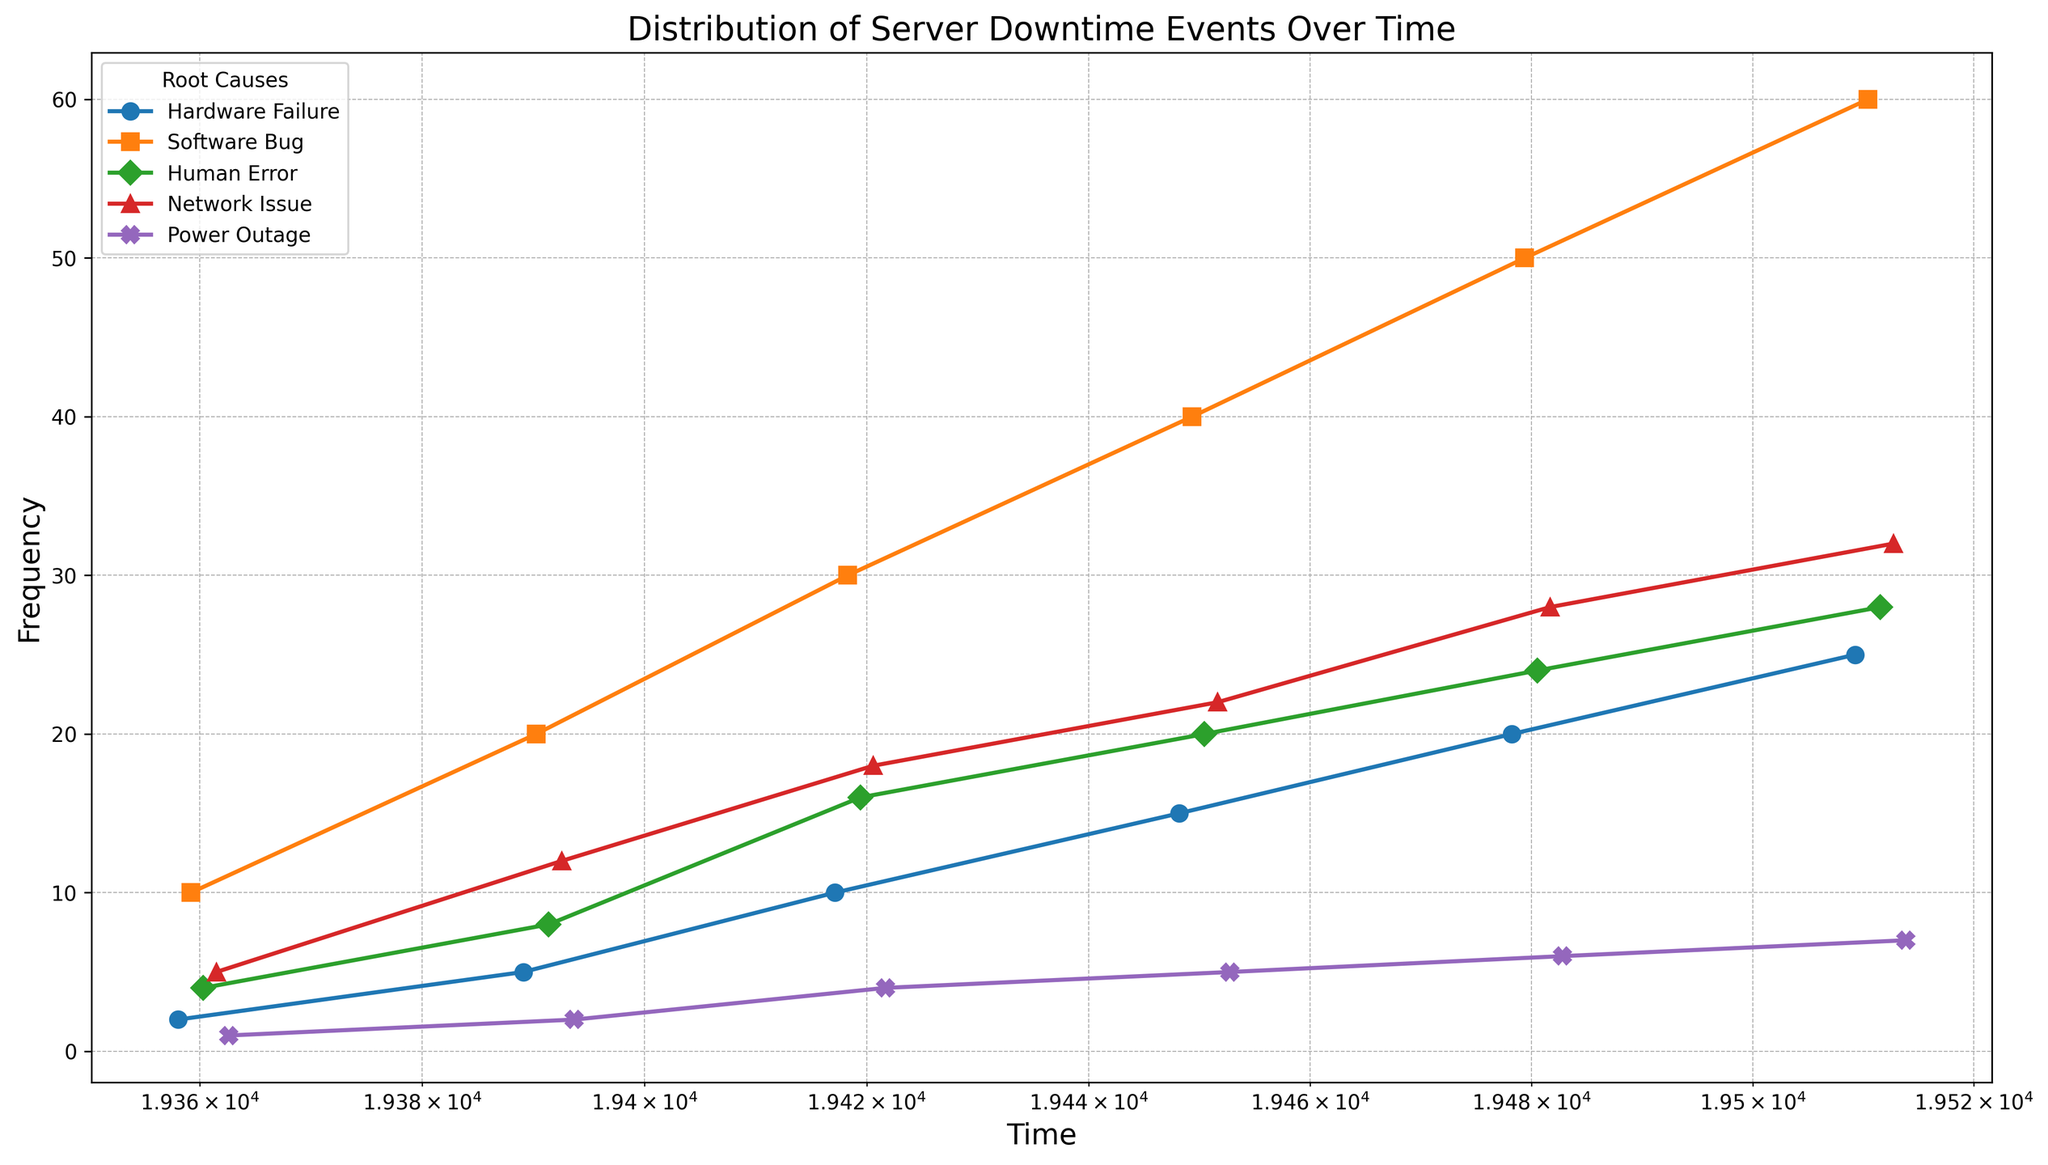Which root cause had the highest frequency of server downtime events in June 2023? By looking at the plot, locate the points in June 2023 and identify the one with the highest frequency. The highest point in June corresponds to Software Bug.
Answer: Software Bug Which root cause consistently increased in frequency from January to June 2023? Follow the lines for each root cause from January to June 2023. The Software Bug line increases steadily over this period.
Answer: Software Bug Compare the frequencies of Network Issue and Human Error in March 2023. Which was higher and by how much? Identify the points for Network Issue and Human Error in March 2023 on the plot. Subtract the frequency of Human Error from that of Network Issue: 18 (Network Issue) - 16 (Human Error) = 2.
Answer: Network Issue, by 2 What's the combined frequency of Power Outage over the entire period? Sum the frequencies of Power Outage at each timestamp: 1 + 2 + 4 + 5 + 6 + 7 = 25.
Answer: 25 In which month did Hardware Failure experience the largest increase in frequency compared to the previous month? Examine the Hardware Failure line and calculate the differences between consecutive months. The largest increase is from April (15) to May (20), which is an increase of 5.
Answer: May 2023 What is the trend for Human Error events over time? Observe the Human Error line across the timeline; it shows an increasing trend.
Answer: Increasing Which root causes are represented by unique markers and colors? Observe the legend of the plot, which shows different markers and colors for each root cause. Each root cause has a unique combination of marker and color.
Answer: All root causes have unique markers and colors How does the frequency of Server Bug events in February compare to those in January? Refer to the points for Software Bug in January and February. In January the frequency is 10, and in February it is 20; hence, the February value is twice that of January.
Answer: 2 times higher How does the frequency of Network Issues in April compare to March? Comparing the frequencies, April (22) vs March (18), Network Issues increased by 4 in April.
Answer: Increased by 4 